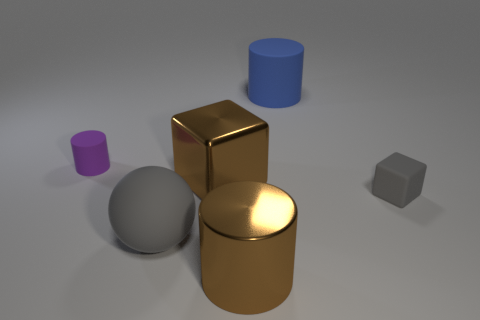Add 3 gray matte objects. How many objects exist? 9 Subtract all spheres. How many objects are left? 5 Add 2 blue rubber cylinders. How many blue rubber cylinders exist? 3 Subtract 0 red cylinders. How many objects are left? 6 Subtract all big shiny cylinders. Subtract all brown shiny cylinders. How many objects are left? 4 Add 2 large brown shiny cubes. How many large brown shiny cubes are left? 3 